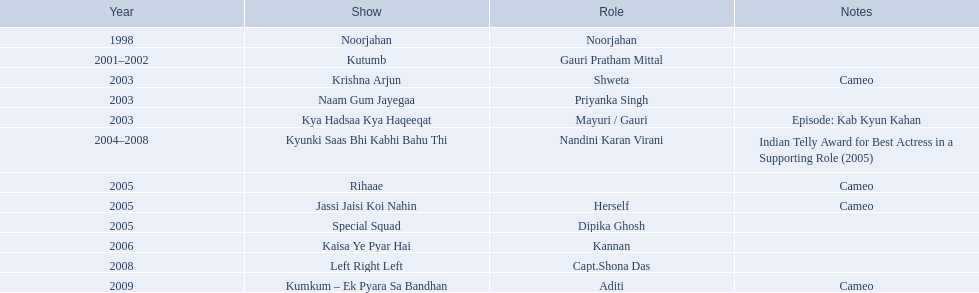Which tv shows featured gauri pradhan tejwani after the year 2000? Kutumb, Krishna Arjun, Naam Gum Jayegaa, Kya Hadsaa Kya Haqeeqat, Kyunki Saas Bhi Kabhi Bahu Thi, Rihaae, Jassi Jaisi Koi Nahin, Special Squad, Kaisa Ye Pyar Hai, Left Right Left, Kumkum – Ek Pyara Sa Bandhan. In which of them did she have a cameo role? Krishna Arjun, Rihaae, Jassi Jaisi Koi Nahin, Kumkum – Ek Pyara Sa Bandhan. Out of these, in which show did she play her own character? Jassi Jaisi Koi Nahin. In 1998, what position did gauri pradhan tejwani hold? Noorjahan. In 2003, which television show featured gauri in a guest appearance? Krishna Arjun. In which tv series did gauri participate for the longest duration? Kyunki Saas Bhi Kabhi Bahu Thi. 